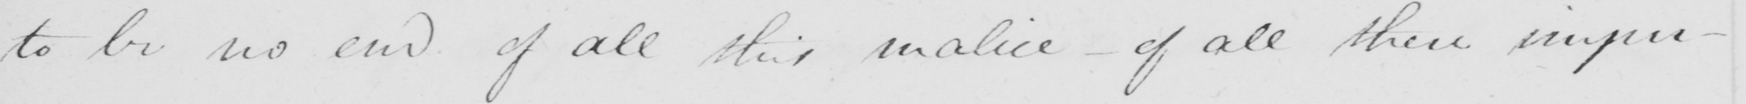Can you tell me what this handwritten text says? to be no end of all this malice  _  of all these impu- 